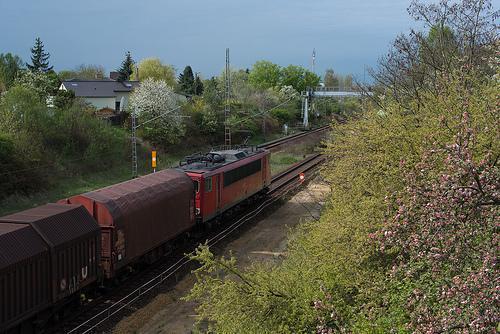How many houses are in the picture?
Give a very brief answer. 1. How many cabooses are in the picture?
Give a very brief answer. 3. How many orange reflectors are there?
Give a very brief answer. 1. 